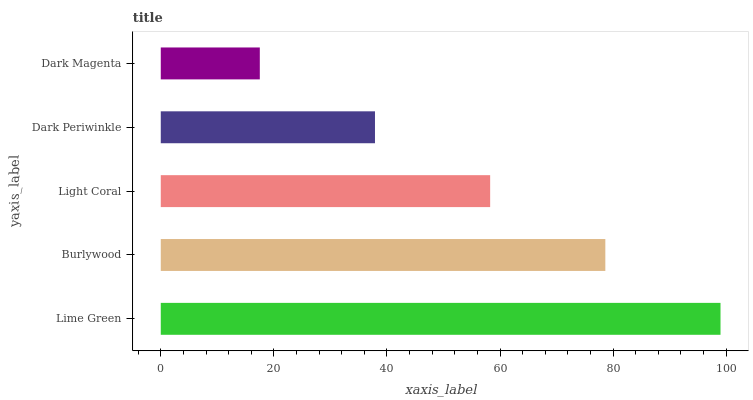Is Dark Magenta the minimum?
Answer yes or no. Yes. Is Lime Green the maximum?
Answer yes or no. Yes. Is Burlywood the minimum?
Answer yes or no. No. Is Burlywood the maximum?
Answer yes or no. No. Is Lime Green greater than Burlywood?
Answer yes or no. Yes. Is Burlywood less than Lime Green?
Answer yes or no. Yes. Is Burlywood greater than Lime Green?
Answer yes or no. No. Is Lime Green less than Burlywood?
Answer yes or no. No. Is Light Coral the high median?
Answer yes or no. Yes. Is Light Coral the low median?
Answer yes or no. Yes. Is Burlywood the high median?
Answer yes or no. No. Is Dark Periwinkle the low median?
Answer yes or no. No. 